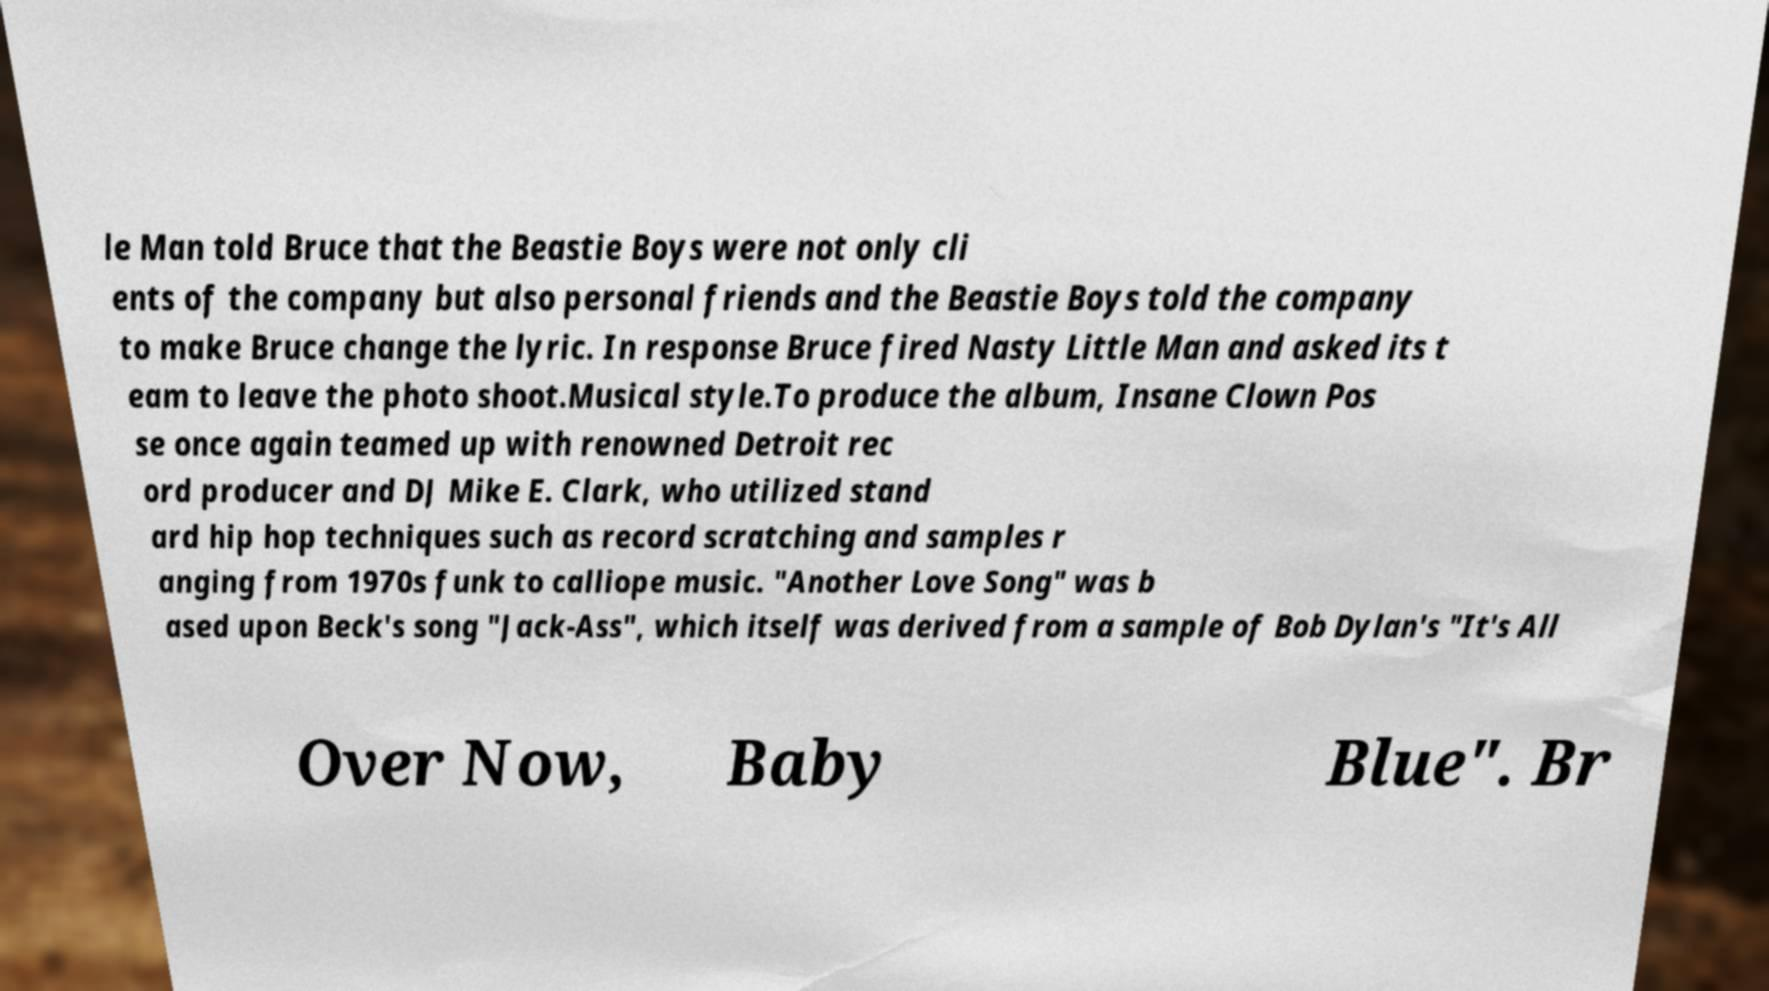For documentation purposes, I need the text within this image transcribed. Could you provide that? le Man told Bruce that the Beastie Boys were not only cli ents of the company but also personal friends and the Beastie Boys told the company to make Bruce change the lyric. In response Bruce fired Nasty Little Man and asked its t eam to leave the photo shoot.Musical style.To produce the album, Insane Clown Pos se once again teamed up with renowned Detroit rec ord producer and DJ Mike E. Clark, who utilized stand ard hip hop techniques such as record scratching and samples r anging from 1970s funk to calliope music. "Another Love Song" was b ased upon Beck's song "Jack-Ass", which itself was derived from a sample of Bob Dylan's "It's All Over Now, Baby Blue". Br 